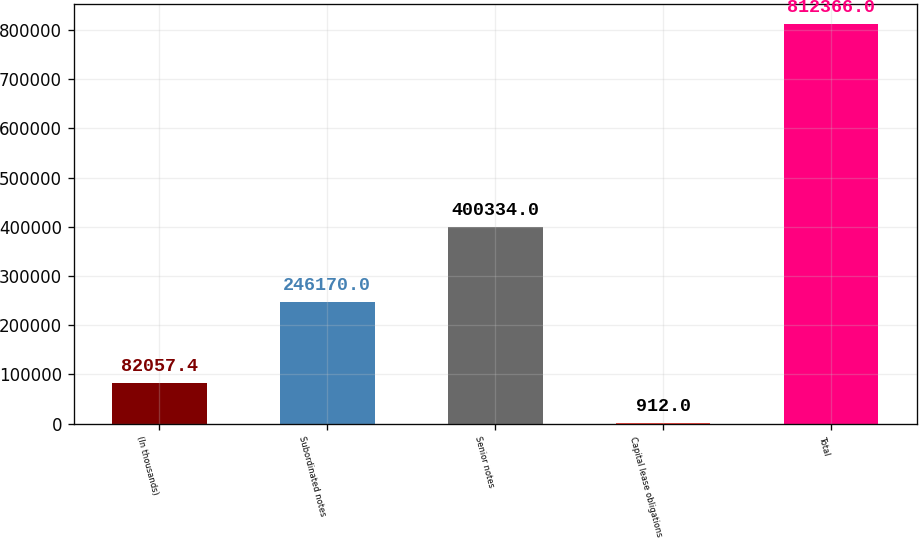<chart> <loc_0><loc_0><loc_500><loc_500><bar_chart><fcel>(In thousands)<fcel>Subordinated notes<fcel>Senior notes<fcel>Capital lease obligations<fcel>Total<nl><fcel>82057.4<fcel>246170<fcel>400334<fcel>912<fcel>812366<nl></chart> 